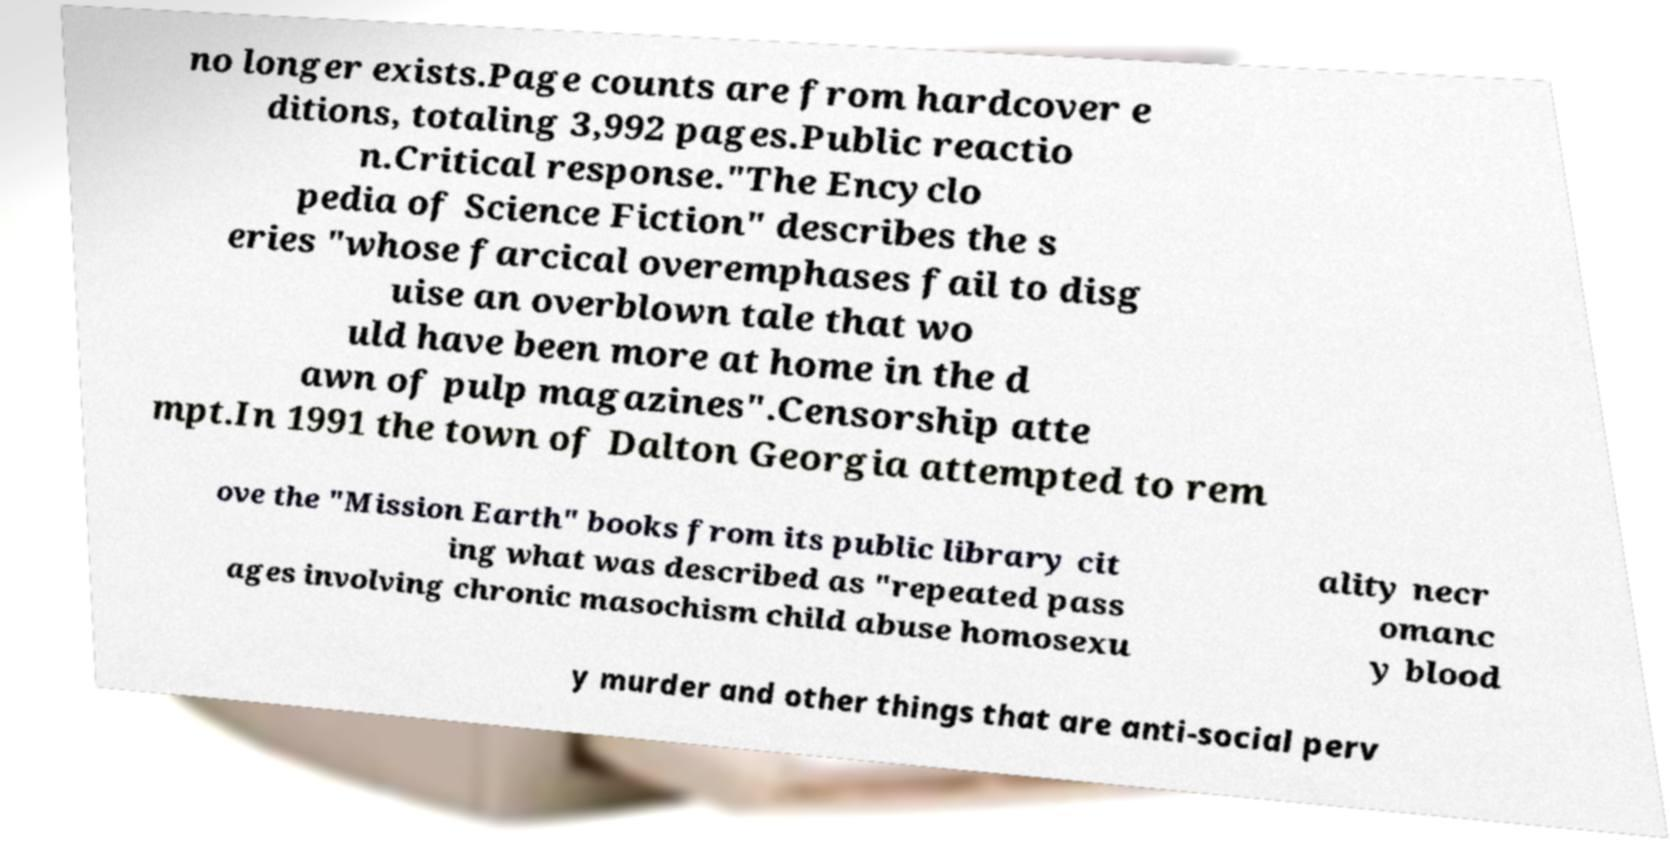There's text embedded in this image that I need extracted. Can you transcribe it verbatim? no longer exists.Page counts are from hardcover e ditions, totaling 3,992 pages.Public reactio n.Critical response."The Encyclo pedia of Science Fiction" describes the s eries "whose farcical overemphases fail to disg uise an overblown tale that wo uld have been more at home in the d awn of pulp magazines".Censorship atte mpt.In 1991 the town of Dalton Georgia attempted to rem ove the "Mission Earth" books from its public library cit ing what was described as "repeated pass ages involving chronic masochism child abuse homosexu ality necr omanc y blood y murder and other things that are anti-social perv 